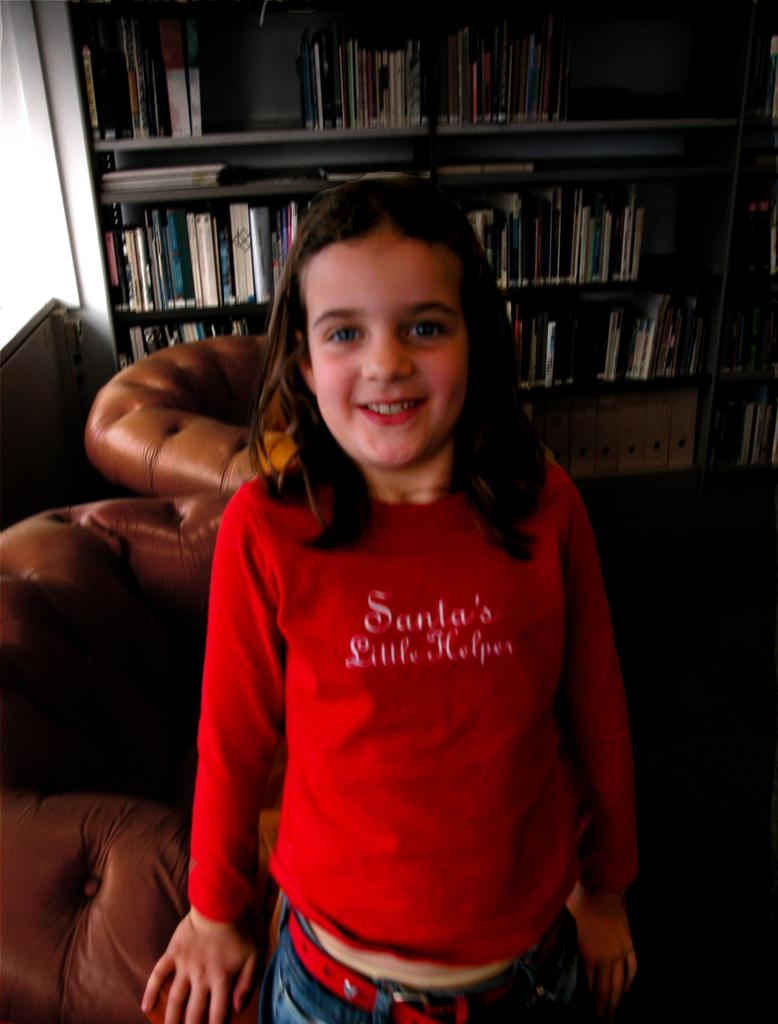<image>
Describe the image concisely. A girl wearing a red Santa's Little Helper shirt stands in front of a bookshelf. 